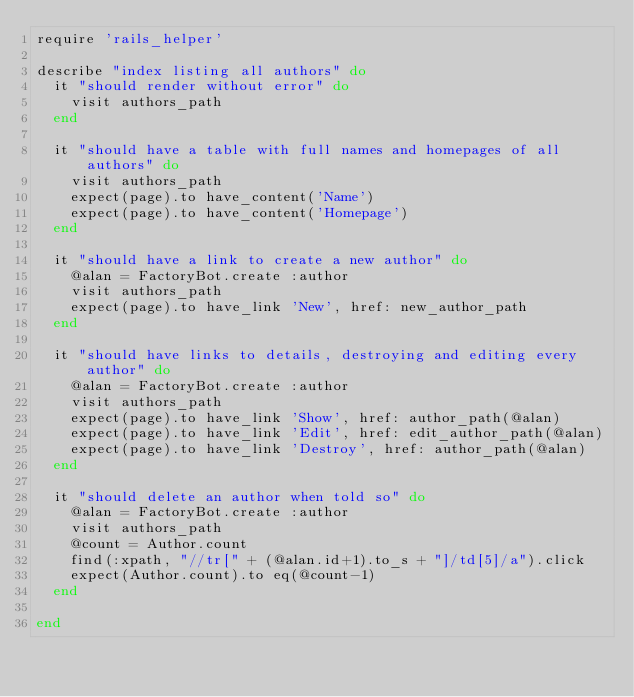Convert code to text. <code><loc_0><loc_0><loc_500><loc_500><_Ruby_>require 'rails_helper'

describe "index listing all authors" do
  it "should render without error" do
    visit authors_path
  end

  it "should have a table with full names and homepages of all authors" do
    visit authors_path
    expect(page).to have_content('Name')
    expect(page).to have_content('Homepage')
  end

  it "should have a link to create a new author" do
    @alan = FactoryBot.create :author
    visit authors_path
    expect(page).to have_link 'New', href: new_author_path
  end

  it "should have links to details, destroying and editing every author" do
    @alan = FactoryBot.create :author
    visit authors_path
    expect(page).to have_link 'Show', href: author_path(@alan)
    expect(page).to have_link 'Edit', href: edit_author_path(@alan)
    expect(page).to have_link 'Destroy', href: author_path(@alan)
  end

  it "should delete an author when told so" do
    @alan = FactoryBot.create :author
    visit authors_path
    @count = Author.count
    find(:xpath, "//tr[" + (@alan.id+1).to_s + "]/td[5]/a").click
    expect(Author.count).to eq(@count-1)
  end

end
</code> 